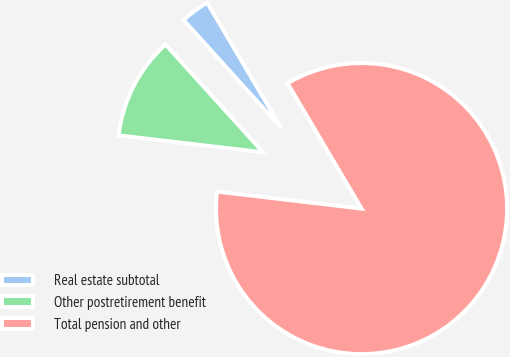Convert chart. <chart><loc_0><loc_0><loc_500><loc_500><pie_chart><fcel>Real estate subtotal<fcel>Other postretirement benefit<fcel>Total pension and other<nl><fcel>3.21%<fcel>11.43%<fcel>85.36%<nl></chart> 